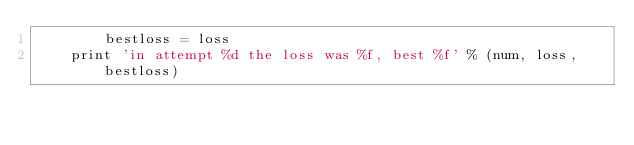Convert code to text. <code><loc_0><loc_0><loc_500><loc_500><_Python_>        bestloss = loss
    print 'in attempt %d the loss was %f, best %f' % (num, loss, bestloss)
</code> 